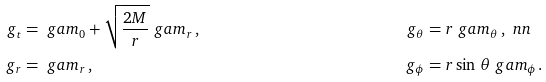<formula> <loc_0><loc_0><loc_500><loc_500>g _ { t } & = \ g a m _ { 0 } + \sqrt { \frac { 2 M } { r } } \ g a m _ { r } \, , & g _ { \theta } & = r \ g a m _ { \theta } \, , \ n n \\ g _ { r } & = \ g a m _ { r } \, , & g _ { \phi } & = r \sin \, \theta \ g a m _ { \phi } .</formula> 